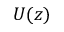Convert formula to latex. <formula><loc_0><loc_0><loc_500><loc_500>U ( z )</formula> 